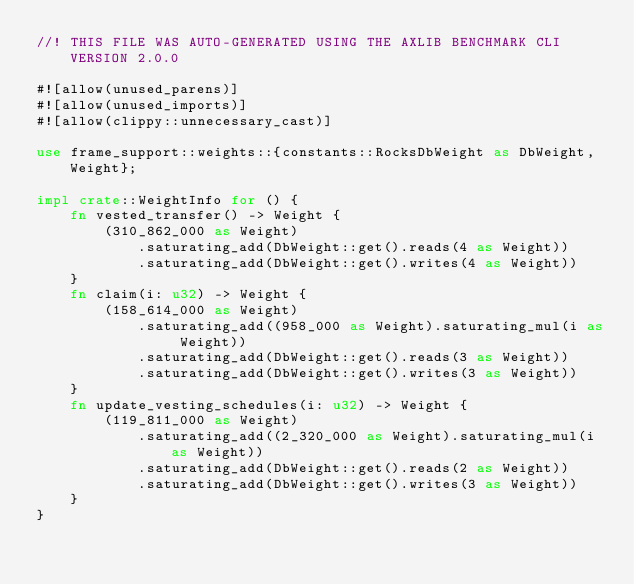Convert code to text. <code><loc_0><loc_0><loc_500><loc_500><_Rust_>//! THIS FILE WAS AUTO-GENERATED USING THE AXLIB BENCHMARK CLI VERSION 2.0.0

#![allow(unused_parens)]
#![allow(unused_imports)]
#![allow(clippy::unnecessary_cast)]

use frame_support::weights::{constants::RocksDbWeight as DbWeight, Weight};

impl crate::WeightInfo for () {
	fn vested_transfer() -> Weight {
		(310_862_000 as Weight)
			.saturating_add(DbWeight::get().reads(4 as Weight))
			.saturating_add(DbWeight::get().writes(4 as Weight))
	}
	fn claim(i: u32) -> Weight {
		(158_614_000 as Weight)
			.saturating_add((958_000 as Weight).saturating_mul(i as Weight))
			.saturating_add(DbWeight::get().reads(3 as Weight))
			.saturating_add(DbWeight::get().writes(3 as Weight))
	}
	fn update_vesting_schedules(i: u32) -> Weight {
		(119_811_000 as Weight)
			.saturating_add((2_320_000 as Weight).saturating_mul(i as Weight))
			.saturating_add(DbWeight::get().reads(2 as Weight))
			.saturating_add(DbWeight::get().writes(3 as Weight))
	}
}
</code> 